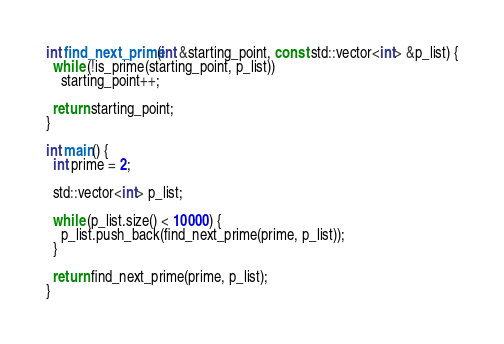Convert code to text. <code><loc_0><loc_0><loc_500><loc_500><_C++_>int find_next_prime(int &starting_point, const std::vector<int> &p_list) {
  while (!is_prime(starting_point, p_list))
    starting_point++;

  return starting_point;
}

int main() {
  int prime = 2;

  std::vector<int> p_list;

  while (p_list.size() < 10000) {
    p_list.push_back(find_next_prime(prime, p_list));
  }

  return find_next_prime(prime, p_list);
}</code> 